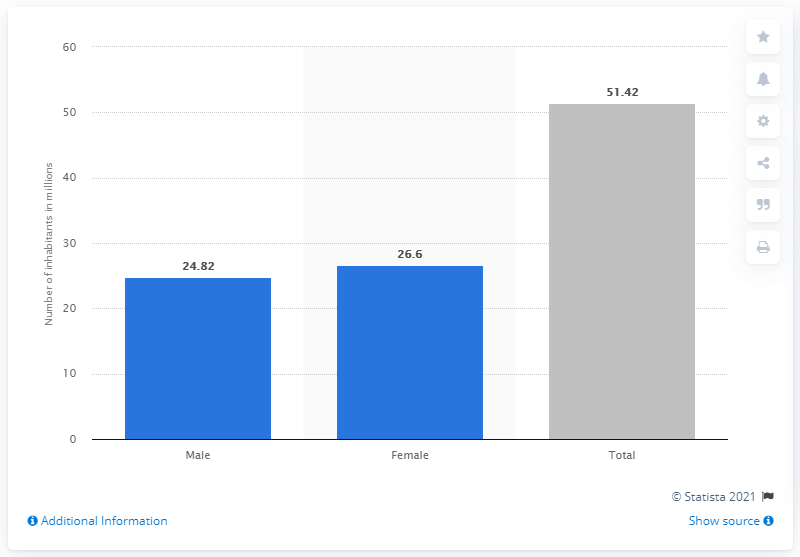Indicate a few pertinent items in this graphic. According to data from 2014, approximately 26.6% of the population of Myanmar were female. In 2014, the estimated number of people living in Myanmar was 51.42 million. 